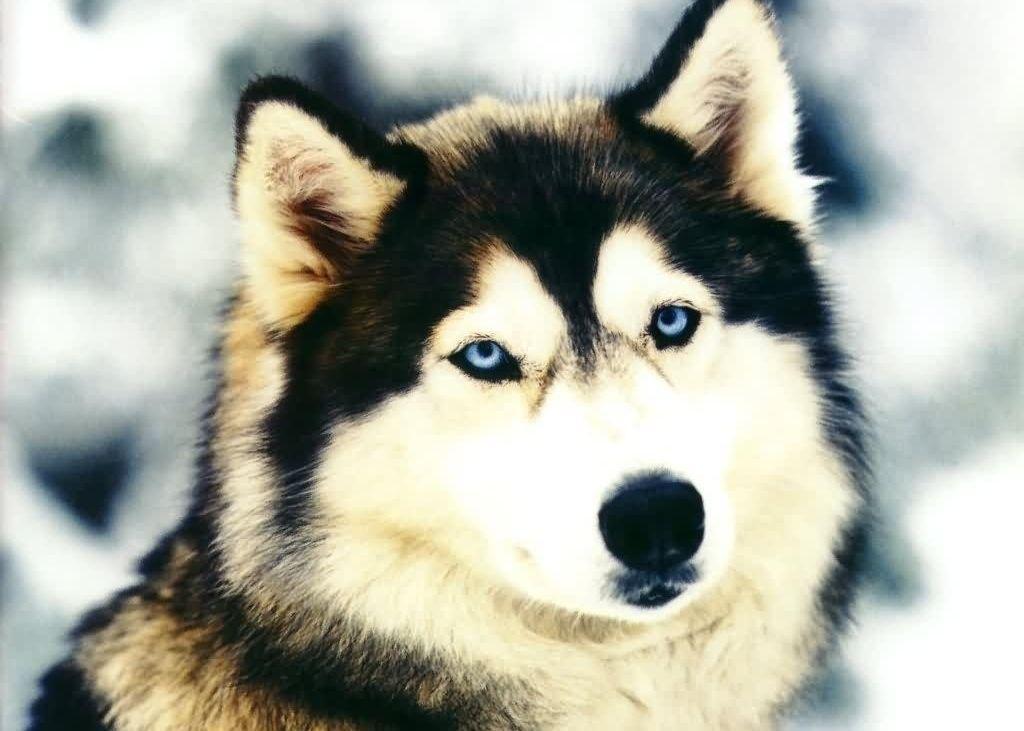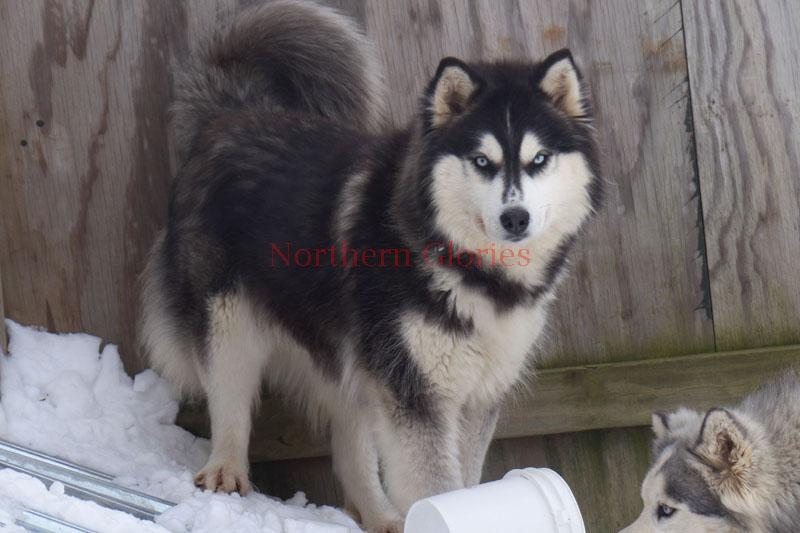The first image is the image on the left, the second image is the image on the right. Given the left and right images, does the statement "Each image contains one prominent camera-gazing husky dog with blue eyes and a closed mouth." hold true? Answer yes or no. Yes. 